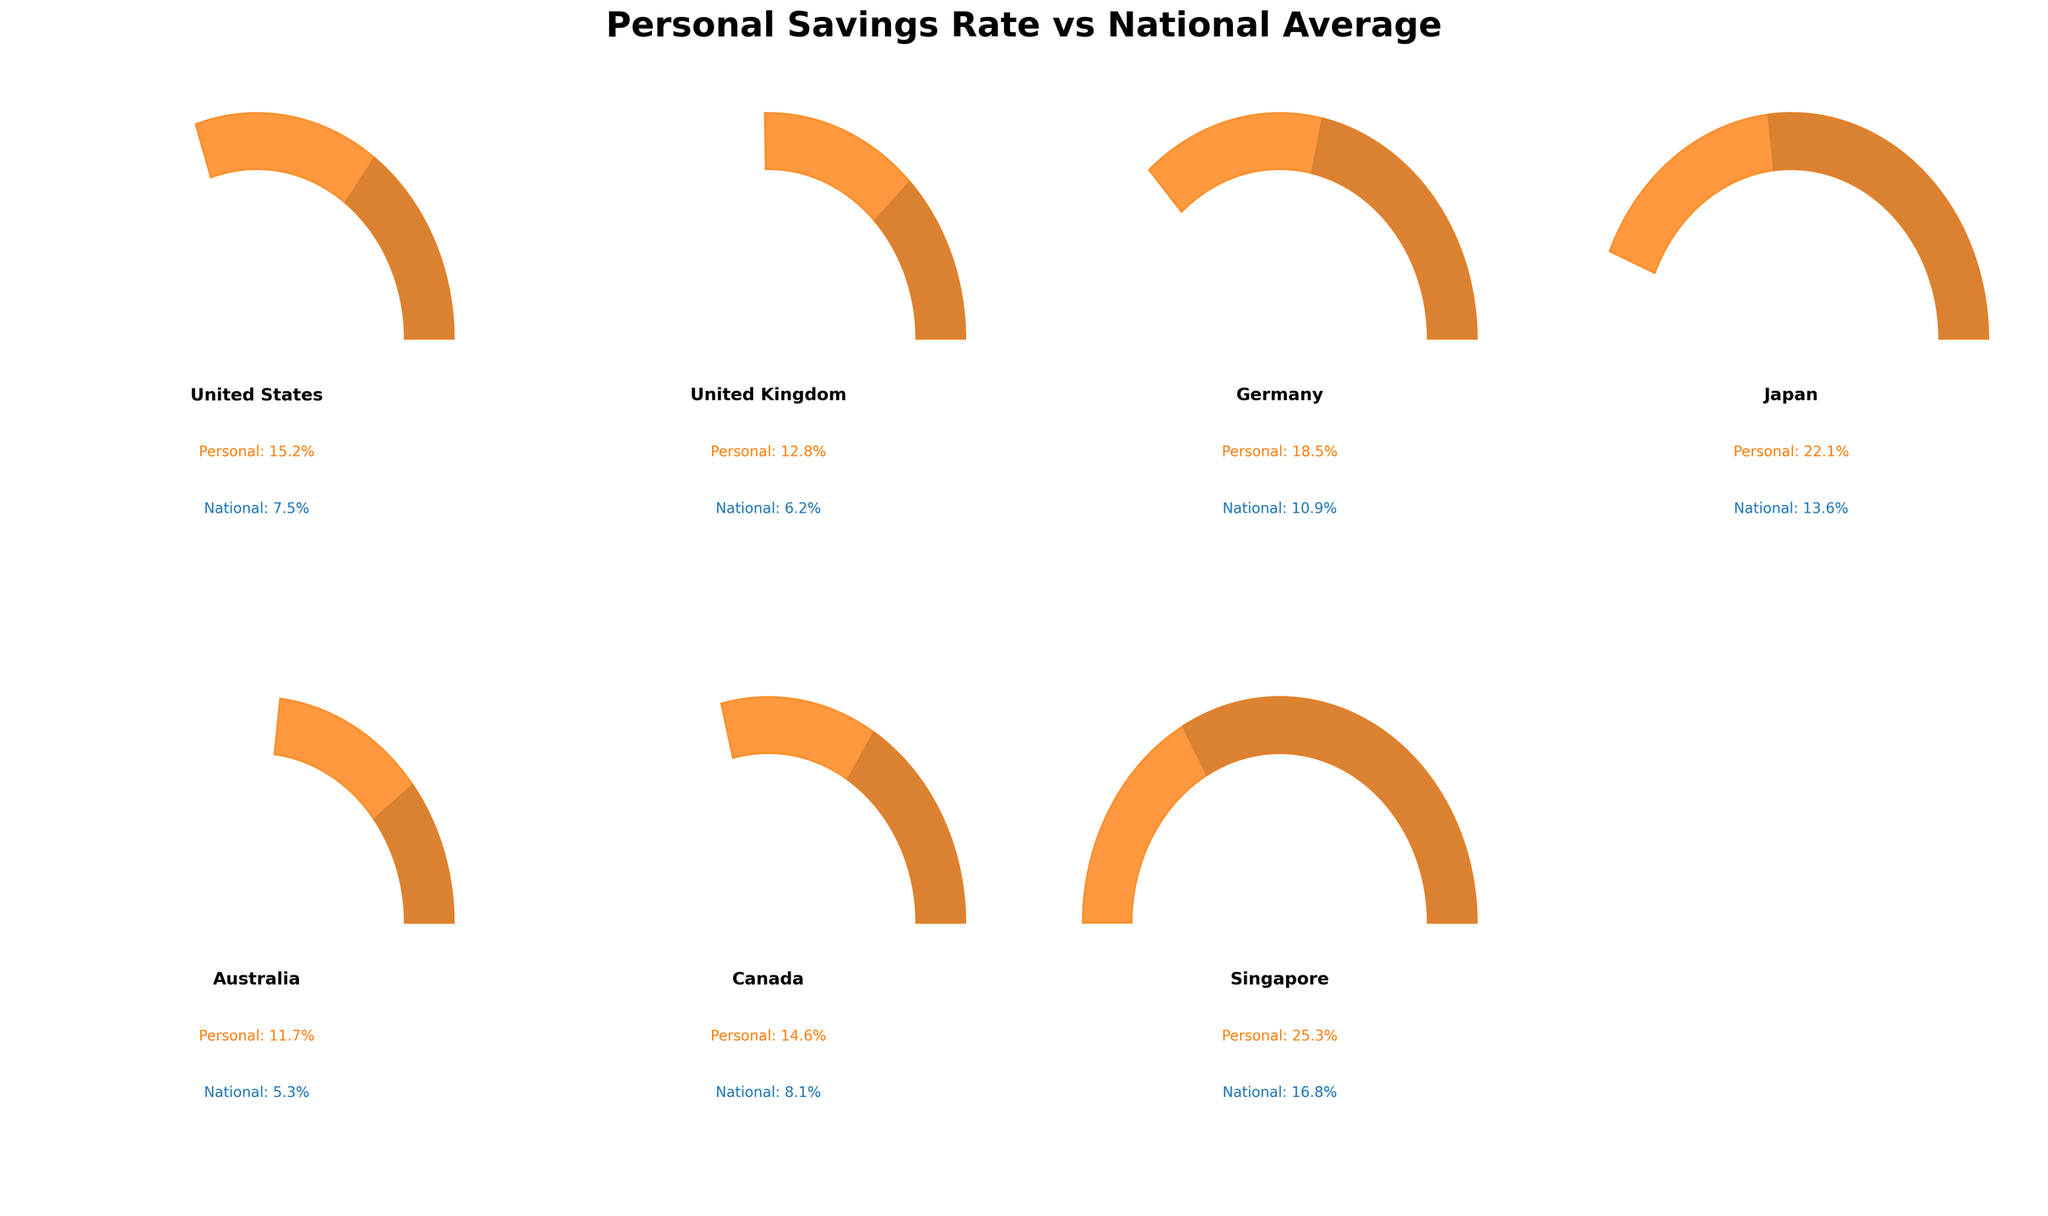How many countries are represented in the figure? Count each individual country shown in the gauges. The countries are the United States, United Kingdom, Germany, Japan, Australia, Canada, and Singapore.
Answer: 7 What is the highest personal savings rate displayed on the figure? Look for the gauge showing the personal savings rate and identify the highest percentage value. The highest value displayed is for Singapore at 25.3%.
Answer: 25.3% Which country has the smallest difference between its personal savings rate and the national average? Subtract the national average from the personal savings rate for each country and find the smallest difference: 
- United States: 15.2 - 7.5 = 7.7
- United Kingdom: 12.8 - 6.2 = 6.6
- Germany: 18.5 - 10.9 = 7.6
- Japan: 22.1 - 13.6 = 8.5
- Australia: 11.7 - 5.3 = 6.4
- Canada: 14.6 - 8.1 = 6.5
- Singapore: 25.3 - 16.8 = 8.5
Australia has the smallest difference at 6.4.
Answer: Australia Which two countries have personal savings rates above 20%? Look for gauges with personal savings rates above 20% and identify the countries. Japan has 22.1% and Singapore has 25.3%.
Answer: Japan and Singapore What's the total of the national averages for all countries? Add the national average percentages for all countries shown in the figure:
7.5 (US) + 6.2 (UK) + 10.9 (Germany) + 13.6 (Japan) + 5.3 (Australia) + 8.1 (Canada) + 16.8 (Singapore) = 68.4%
Answer: 68.4% Which country has the closest personal savings rate to the national average? Identify the country where the personal savings rate and national average are closest in value. From previous calculations of differences, United Kingdom (6.6) and Canada (6.5), but Canada has the closest difference of 6.5.
Answer: Canada How does the personal savings rate of the United States compare to the national average of Canada? Compare the two numerical values: The United States' savings rate is 15.2%, and the national average for Canada is 8.1%. Then, 15.2% > 8.1%.
Answer: Higher Are there any countries with a national average greater than the personal savings rate of the United States? Identify if any country's national average exceeds 15.2%. Singapore's national average is 16.8%, which is the only one higher than 15.2%.
Answer: Yes, Singapore What is the difference between the highest and lowest personal savings rates shown? Identify the highest personal savings rate (Singapore 25.3%) and lowest (Australia 11.7%), then subtract them: 
25.3 - 11.7 = 13.6
Answer: 13.6% Which country has the most noticeable difference between personal savings rate and national average in terms of wedge size in the gauge? Visually inspect the gaps in the gauges where personal savings rates significantly exceed the national averages. Singapore has the most noticeable difference with a gap from 16.8 to 25.3 in the chart.
Answer: Singapore 